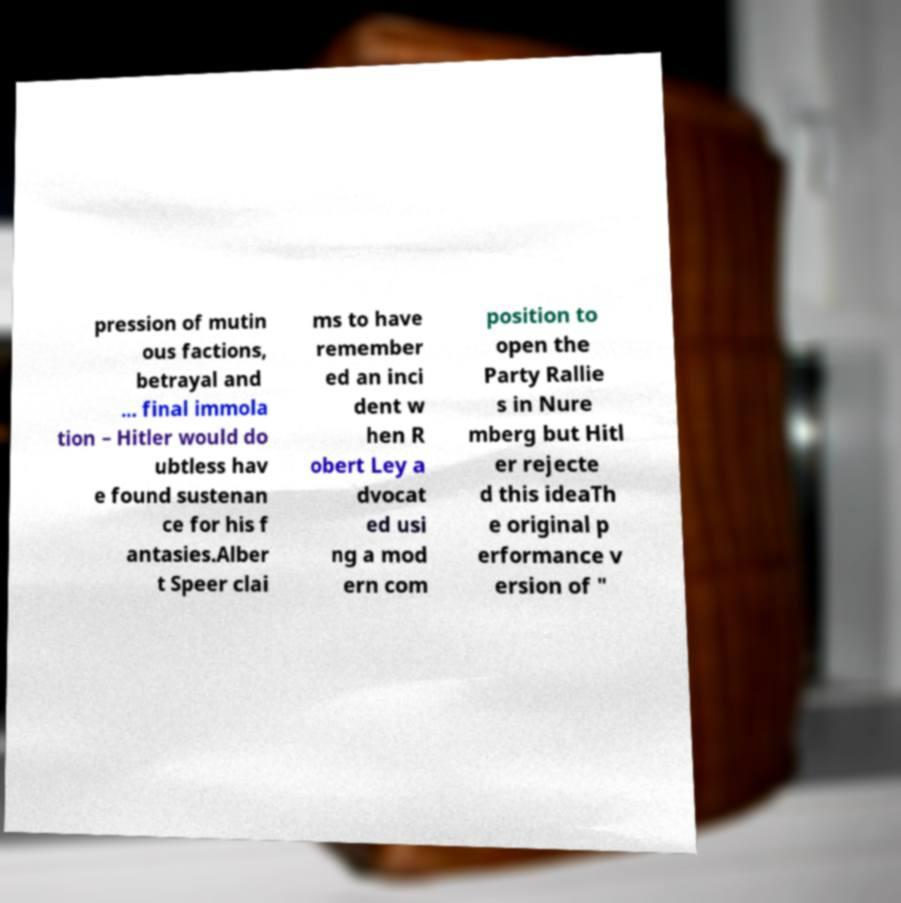What messages or text are displayed in this image? I need them in a readable, typed format. pression of mutin ous factions, betrayal and ... final immola tion – Hitler would do ubtless hav e found sustenan ce for his f antasies.Alber t Speer clai ms to have remember ed an inci dent w hen R obert Ley a dvocat ed usi ng a mod ern com position to open the Party Rallie s in Nure mberg but Hitl er rejecte d this ideaTh e original p erformance v ersion of " 